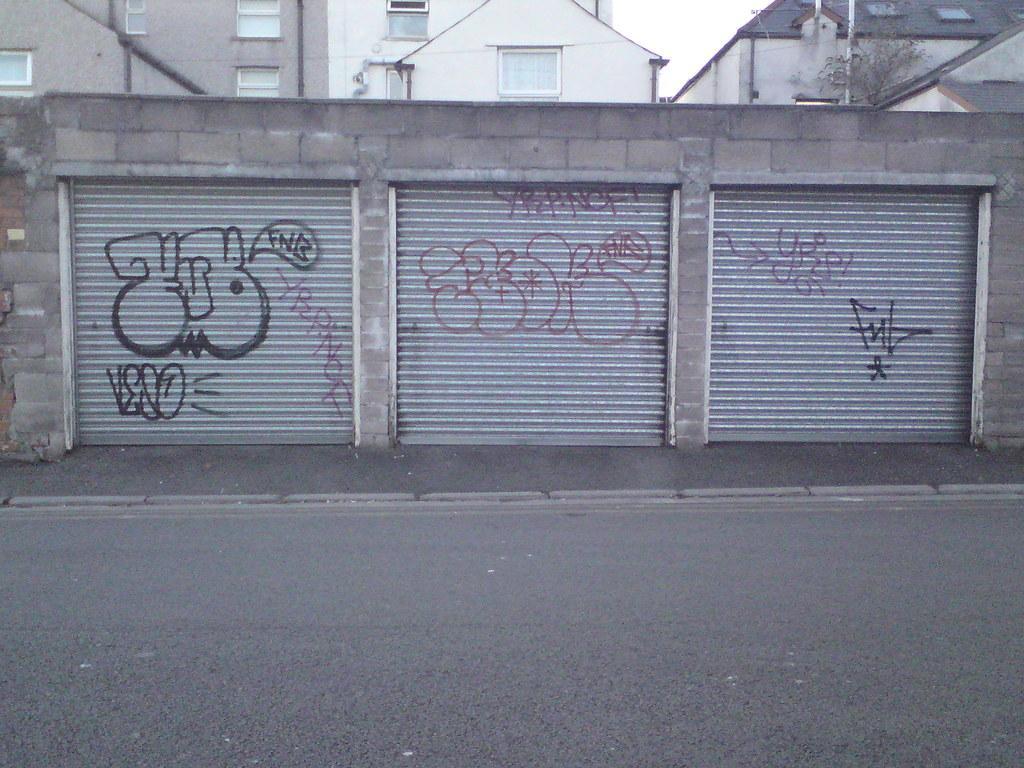Please provide a concise description of this image. In this picture we can see a few shutters. There is a road. We can see few buildings in the background. There is a plant and a rod on the right side. 